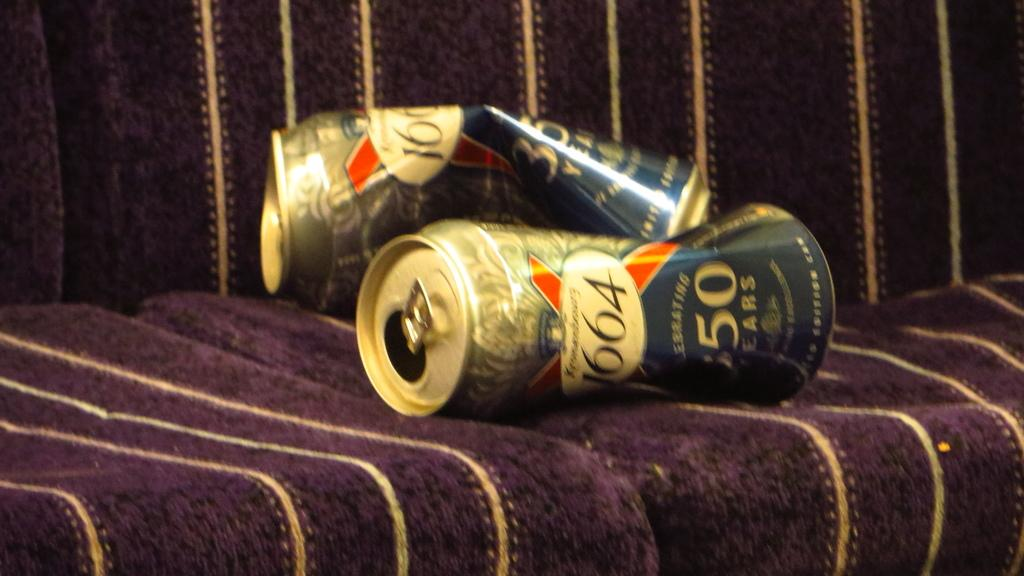<image>
Relay a brief, clear account of the picture shown. Two crumpled cans of 1664 rest on a couch. 